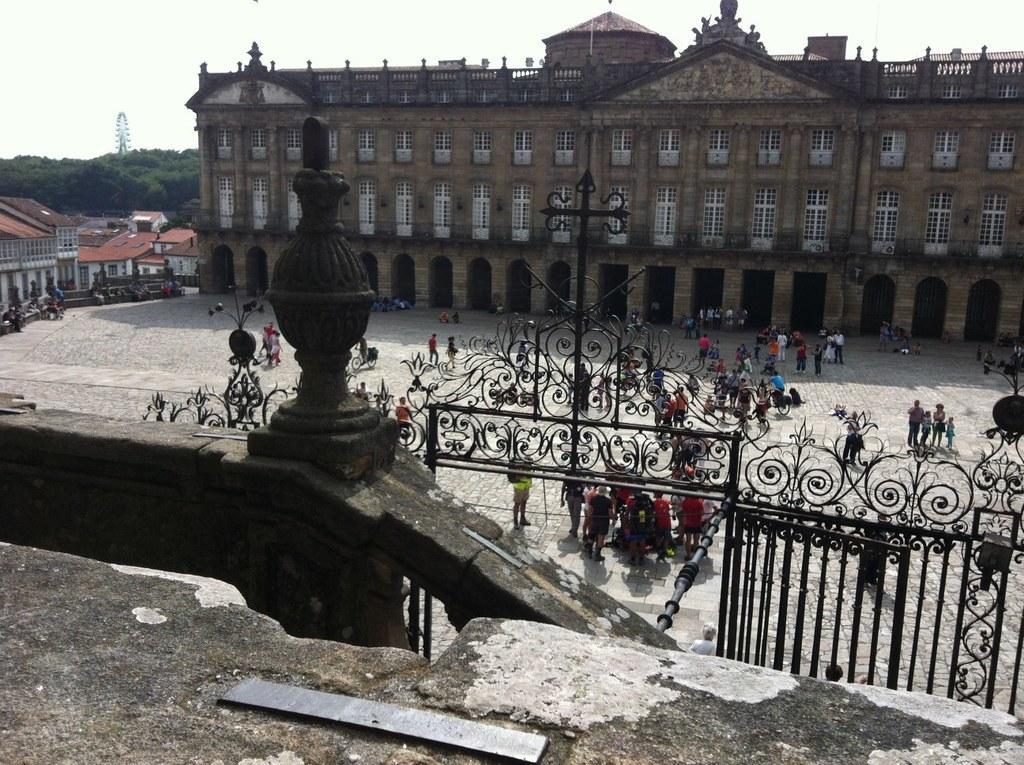Please provide a concise description of this image. In the image we can see the buildings and these are the windows of the building. There are even people around, wearing clothes. Here we can see fence, footpath, tree, tower and a sky. 